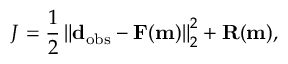<formula> <loc_0><loc_0><loc_500><loc_500>J = \frac { 1 } { 2 } \left \| d _ { o b s } - F ( m ) \right \| _ { 2 } ^ { 2 } + R ( m ) ,</formula> 